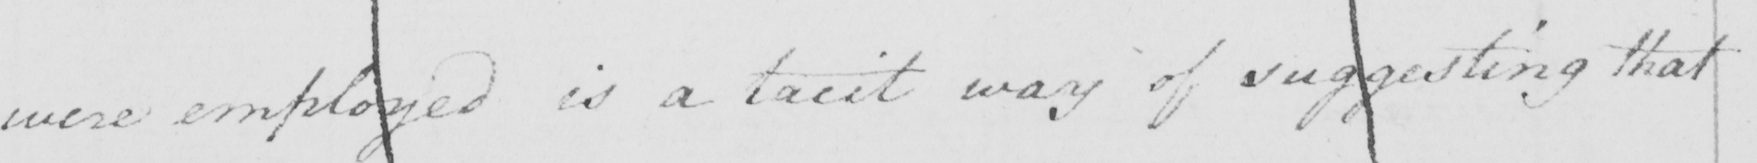Please transcribe the handwritten text in this image. were employed is a tacit way of suggesting that 